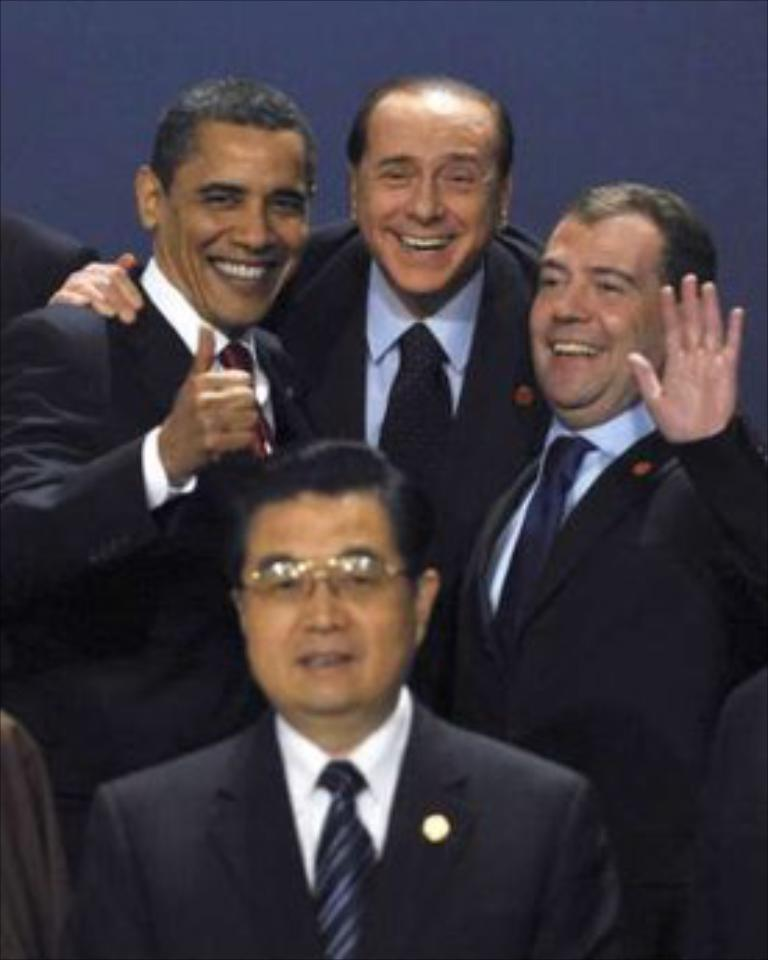How many people are present in the image? There are four people in the image. What are the people wearing in the image? The people are wearing blazers in the image. What color are the blazers? The blazers are black in color. What can be seen in the background of the image? There is a blue wall in the background of the image. What type of fish can be seen swimming on the stage in the image? There is no fish or stage present in the image; it features four people wearing black blazers in front of a blue wall. 